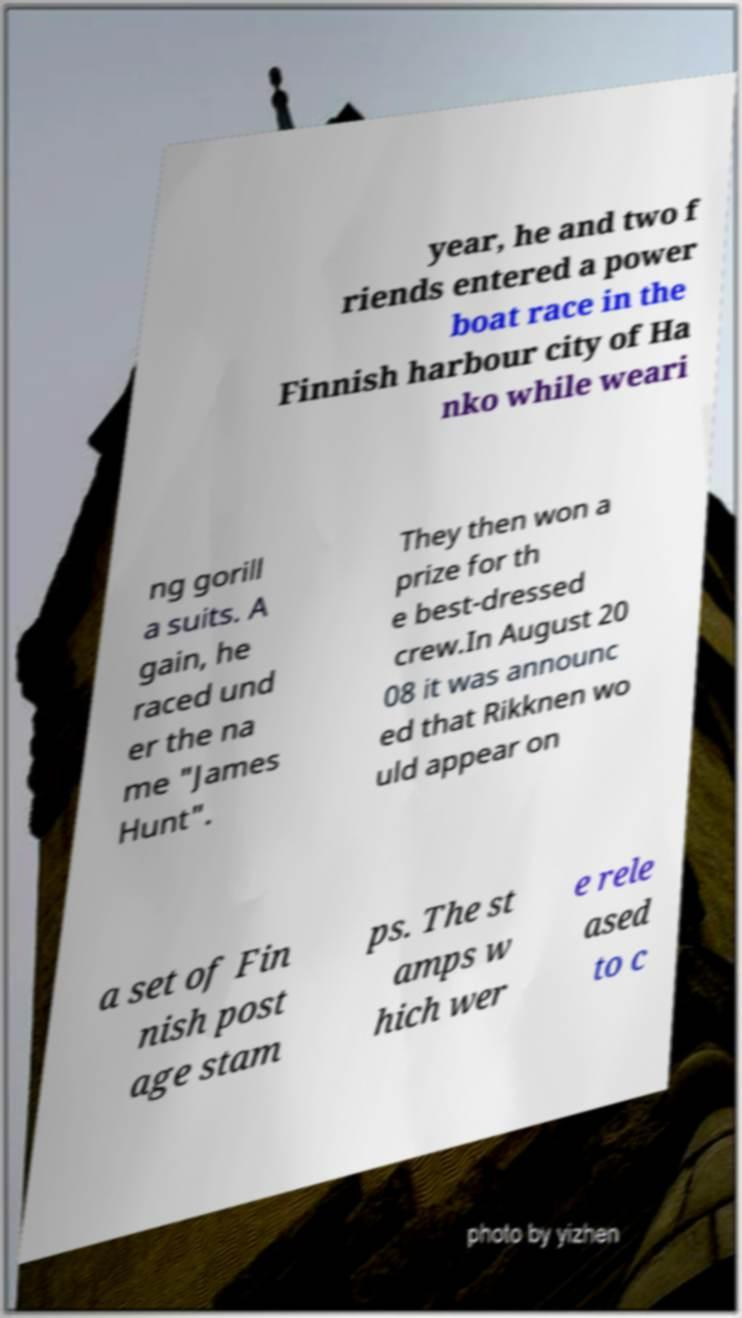I need the written content from this picture converted into text. Can you do that? year, he and two f riends entered a power boat race in the Finnish harbour city of Ha nko while weari ng gorill a suits. A gain, he raced und er the na me "James Hunt". They then won a prize for th e best-dressed crew.In August 20 08 it was announc ed that Rikknen wo uld appear on a set of Fin nish post age stam ps. The st amps w hich wer e rele ased to c 